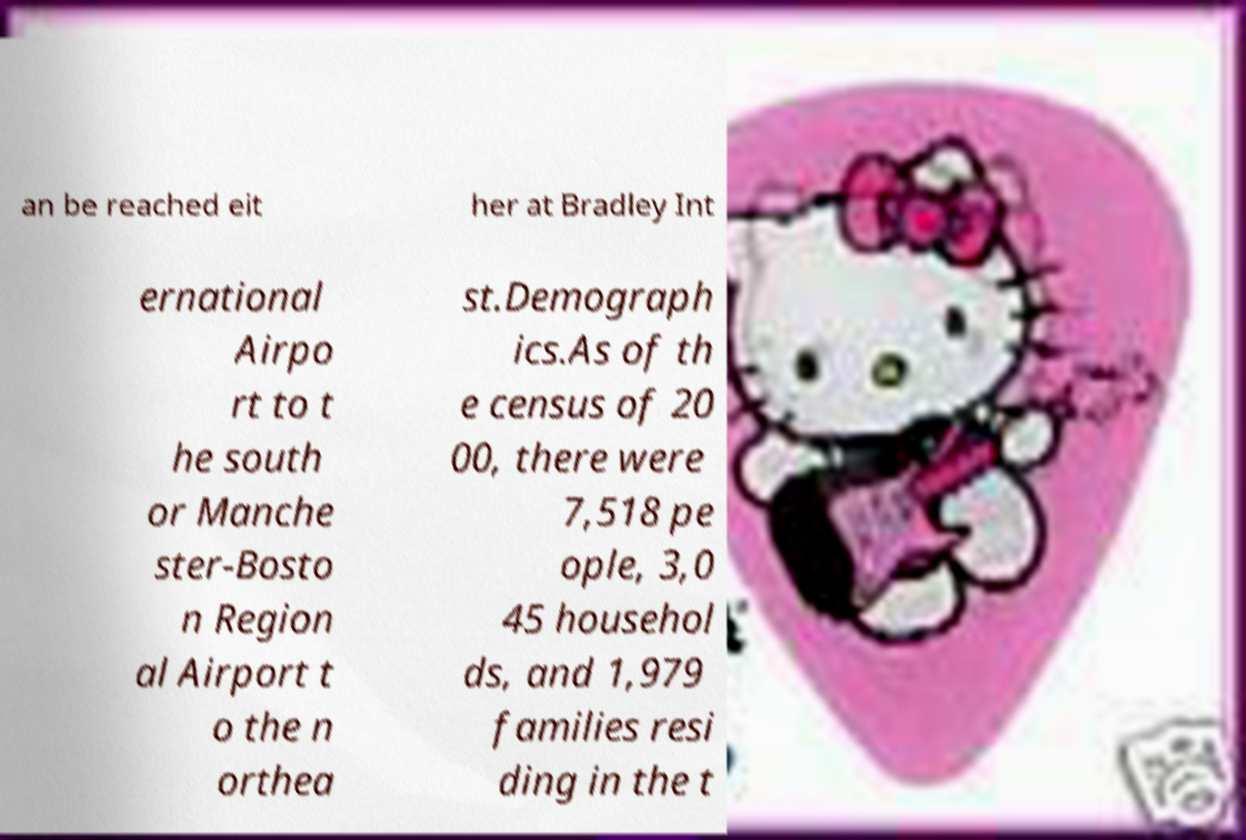Could you extract and type out the text from this image? an be reached eit her at Bradley Int ernational Airpo rt to t he south or Manche ster-Bosto n Region al Airport t o the n orthea st.Demograph ics.As of th e census of 20 00, there were 7,518 pe ople, 3,0 45 househol ds, and 1,979 families resi ding in the t 